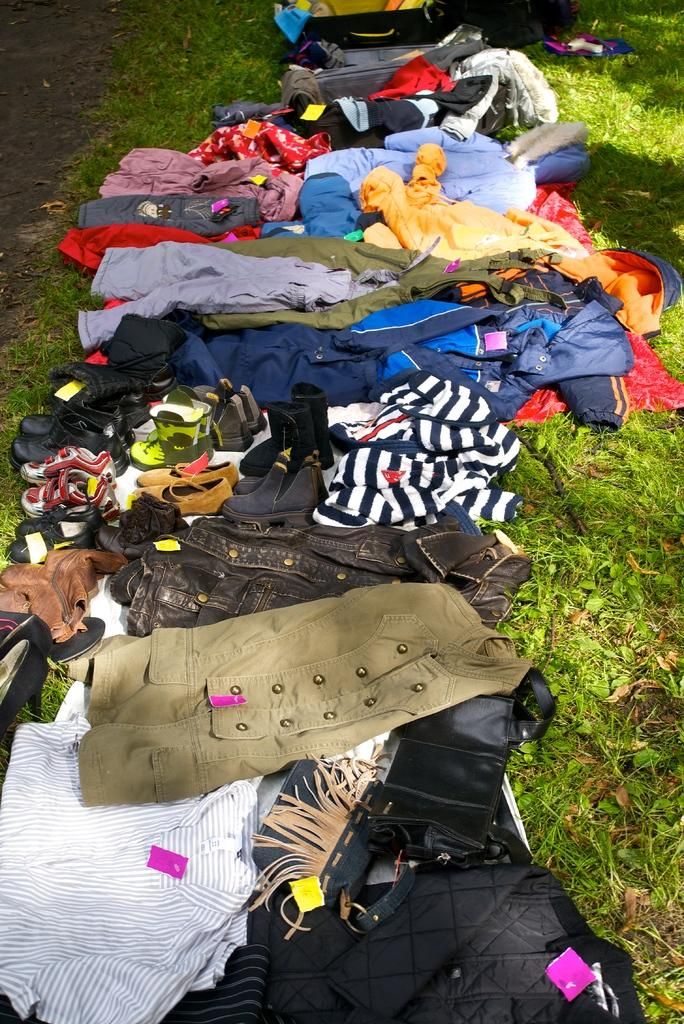What type of surface is visible in the image? There is a grass surface in the image. What is placed on the grass surface? There are clothes placed on the grass surface. What else can be seen in the image besides the clothes? There is footwear visible in the image. What rhythm is being played in the background of the image? There is no background music or rhythm present in the image. 